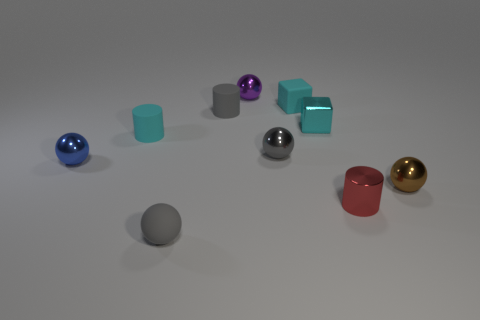Subtract all blue spheres. How many spheres are left? 4 Subtract all brown spheres. How many spheres are left? 4 Subtract all green balls. Subtract all yellow blocks. How many balls are left? 5 Subtract all large yellow things. Subtract all cyan blocks. How many objects are left? 8 Add 2 metallic blocks. How many metallic blocks are left? 3 Add 8 tiny metal cylinders. How many tiny metal cylinders exist? 9 Subtract 0 purple blocks. How many objects are left? 10 Subtract all cubes. How many objects are left? 8 